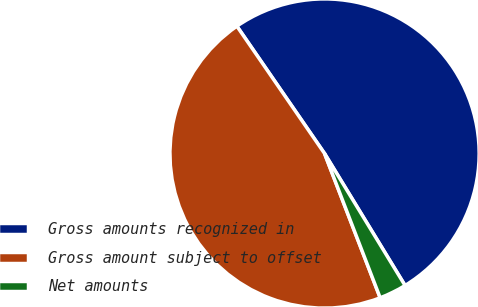<chart> <loc_0><loc_0><loc_500><loc_500><pie_chart><fcel>Gross amounts recognized in<fcel>Gross amount subject to offset<fcel>Net amounts<nl><fcel>50.88%<fcel>46.26%<fcel>2.86%<nl></chart> 